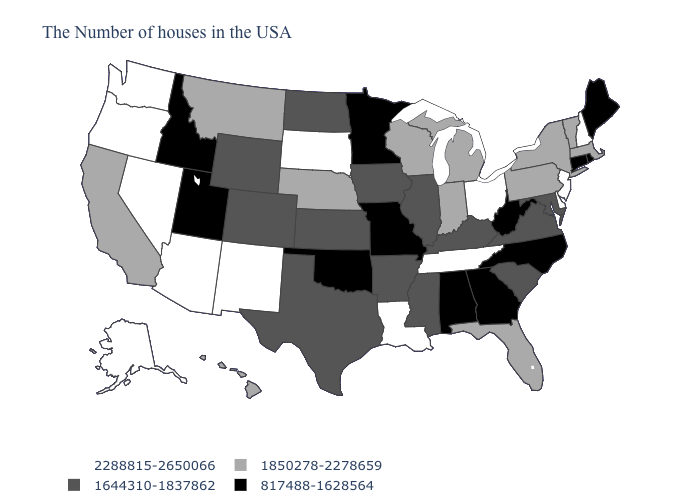Which states hav the highest value in the Northeast?
Answer briefly. New Hampshire, New Jersey. Among the states that border Iowa , does Missouri have the lowest value?
Concise answer only. Yes. Name the states that have a value in the range 2288815-2650066?
Quick response, please. New Hampshire, New Jersey, Delaware, Ohio, Tennessee, Louisiana, South Dakota, New Mexico, Arizona, Nevada, Washington, Oregon, Alaska. Name the states that have a value in the range 817488-1628564?
Keep it brief. Maine, Rhode Island, Connecticut, North Carolina, West Virginia, Georgia, Alabama, Missouri, Minnesota, Oklahoma, Utah, Idaho. Name the states that have a value in the range 1850278-2278659?
Short answer required. Massachusetts, Vermont, New York, Pennsylvania, Florida, Michigan, Indiana, Wisconsin, Nebraska, Montana, California, Hawaii. Which states have the lowest value in the USA?
Quick response, please. Maine, Rhode Island, Connecticut, North Carolina, West Virginia, Georgia, Alabama, Missouri, Minnesota, Oklahoma, Utah, Idaho. Does Maryland have a higher value than Missouri?
Quick response, please. Yes. What is the value of Massachusetts?
Give a very brief answer. 1850278-2278659. Name the states that have a value in the range 1850278-2278659?
Concise answer only. Massachusetts, Vermont, New York, Pennsylvania, Florida, Michigan, Indiana, Wisconsin, Nebraska, Montana, California, Hawaii. What is the value of Indiana?
Short answer required. 1850278-2278659. What is the lowest value in states that border New Hampshire?
Quick response, please. 817488-1628564. What is the value of California?
Be succinct. 1850278-2278659. Does Massachusetts have a lower value than New Jersey?
Be succinct. Yes. Which states have the lowest value in the USA?
Write a very short answer. Maine, Rhode Island, Connecticut, North Carolina, West Virginia, Georgia, Alabama, Missouri, Minnesota, Oklahoma, Utah, Idaho. Name the states that have a value in the range 1850278-2278659?
Answer briefly. Massachusetts, Vermont, New York, Pennsylvania, Florida, Michigan, Indiana, Wisconsin, Nebraska, Montana, California, Hawaii. 